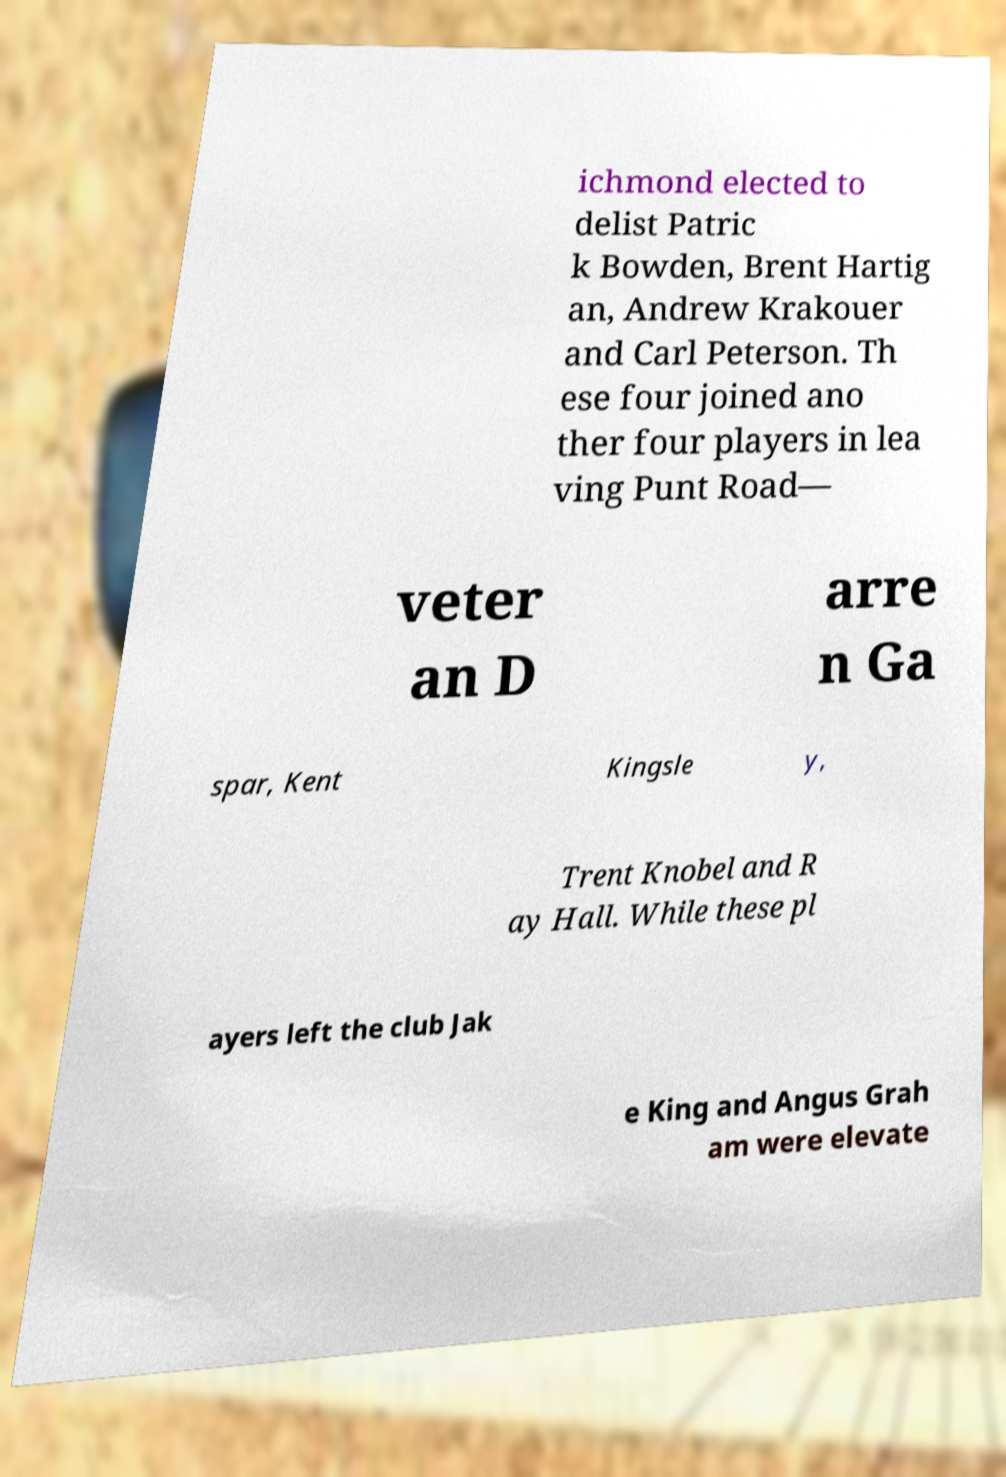I need the written content from this picture converted into text. Can you do that? ichmond elected to delist Patric k Bowden, Brent Hartig an, Andrew Krakouer and Carl Peterson. Th ese four joined ano ther four players in lea ving Punt Road— veter an D arre n Ga spar, Kent Kingsle y, Trent Knobel and R ay Hall. While these pl ayers left the club Jak e King and Angus Grah am were elevate 